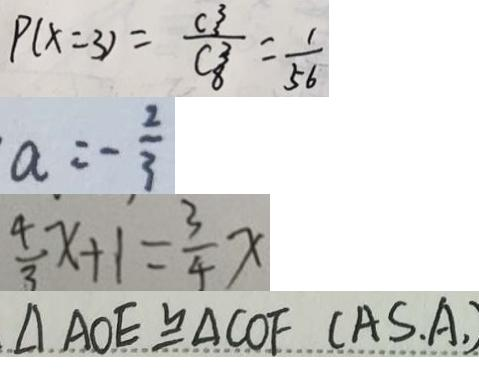Convert formula to latex. <formula><loc_0><loc_0><loc_500><loc_500>P ( x = 3 ) = \frac { C ^ { 3 ^ { 3 } } } { C _ { 8 ^ { 3 } } } = \frac { 1 } { 5 6 } 
 a = - \frac { 2 } { 3 } 
 \frac { 4 } { 3 } x + 1 = \frac { 3 } { 4 } x 
 \Delta A O E \cong \Delta C O F ( A S . A , )</formula> 